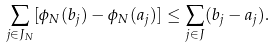Convert formula to latex. <formula><loc_0><loc_0><loc_500><loc_500>\sum _ { j \in J _ { N } } [ \phi _ { N } ( b _ { j } ) - \phi _ { N } ( a _ { j } ) ] \leq \sum _ { j \in J } ( b _ { j } - a _ { j } ) .</formula> 